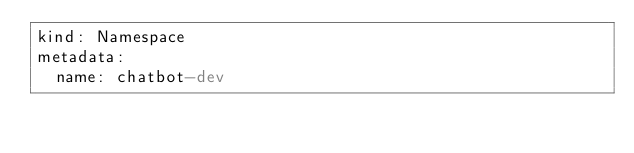<code> <loc_0><loc_0><loc_500><loc_500><_YAML_>kind: Namespace
metadata:
  name: chatbot-dev
</code> 